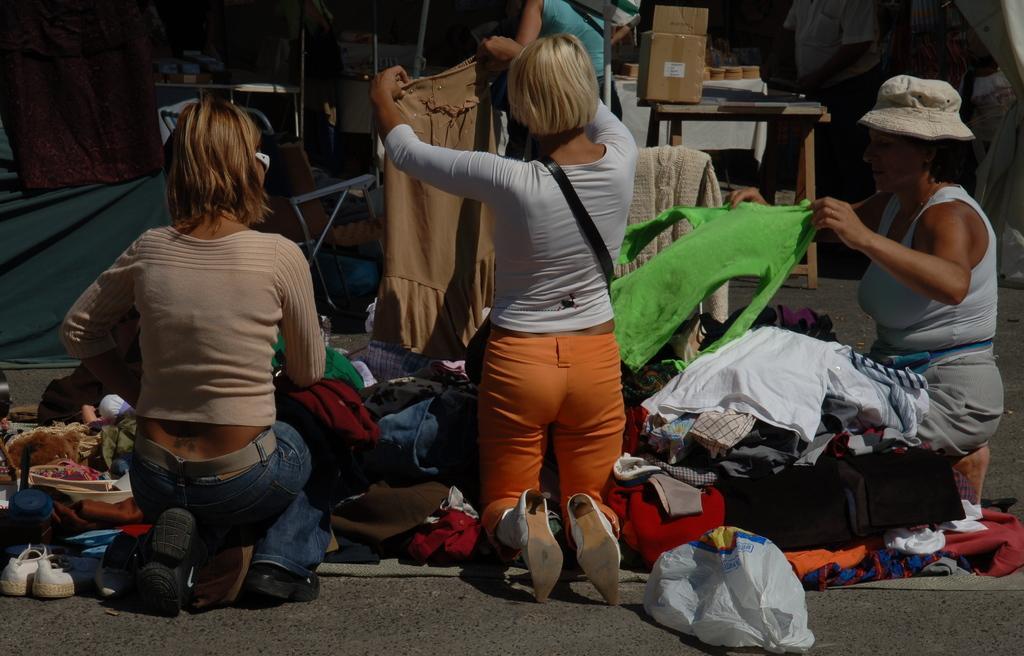Please provide a concise description of this image. In this image, I can see few people and there are clothes on the road. In the background, I can see a cardboard box and few other objects on the tables and there is a chair. On the left side of the image, there are clothes. At the bottom of the image, I can see footwear and a plastic bag. 